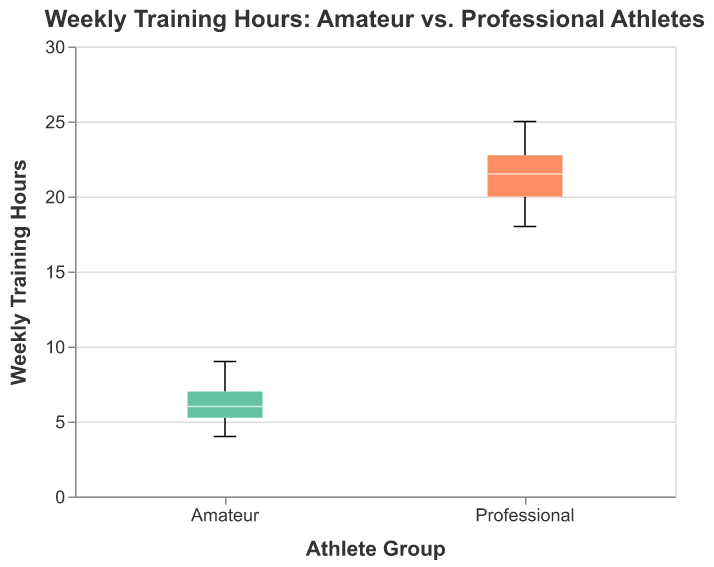What is the title of the figure? The title is displayed at the top of the figure and provides information on what the plot represents.
Answer: Weekly Training Hours: Amateur vs. Professional Athletes How many groups are compared in the figure? The x-axis shows two distinct groups: "Amateur" and "Professional."
Answer: Two What is the range of weekly training hours for amateur athletes? The range is determined by the minimum and maximum values of the boxplot for the "Amateur" group on the y-axis.
Answer: 4 to 9 What's the median weekly training hours for professional athletes? The median is represented by the white line inside the box for the "Professional" group.
Answer: 21 Which group has the highest maximum value of weekly training hours? The maximum value can be identified by the upper whisker of each group. The "Professional" group has the highest at 25 hours.
Answer: Professional What's the interquartile range (IQR) for the amateur group? The IQR is the difference between the third quartile (Q3) and the first quartile (Q1). Visually, this is represented by the box's top and bottom in the "Amateur" group.
Answer: 2 (7 - 5) Compare the median weekly training hours between amateur and professional athletes. The white lines inside the boxes represent the medians. The "Amateur" group has a median around 6, while the "Professional" group has a median of 21.
Answer: Professional athletes have a significantly higher median at 21 compared to amateurs at 6 What is the lower whisker's value for professional athletes? The lower whisker extends to the minimum value within 1.5 times the IQR from the first quartile for the professional group, which is at 18.
Answer: 18 Are there any outliers in the amateur group? Outliers would be shown as individual points outside the whiskers in the "Amateur" group. Since there are no such points, there are no outliers.
Answer: No What's the difference between the highest and lowest weekly training hours recorded for professional athletes? The highest value is the maximum whisker at 25 and the lowest value is the minimum whisker at 18. So, the difference is 25 - 18 = 7.
Answer: 7 